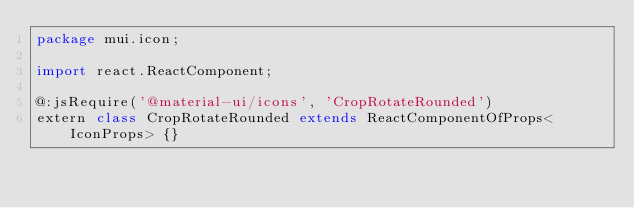Convert code to text. <code><loc_0><loc_0><loc_500><loc_500><_Haxe_>package mui.icon;

import react.ReactComponent;

@:jsRequire('@material-ui/icons', 'CropRotateRounded')
extern class CropRotateRounded extends ReactComponentOfProps<IconProps> {}
</code> 